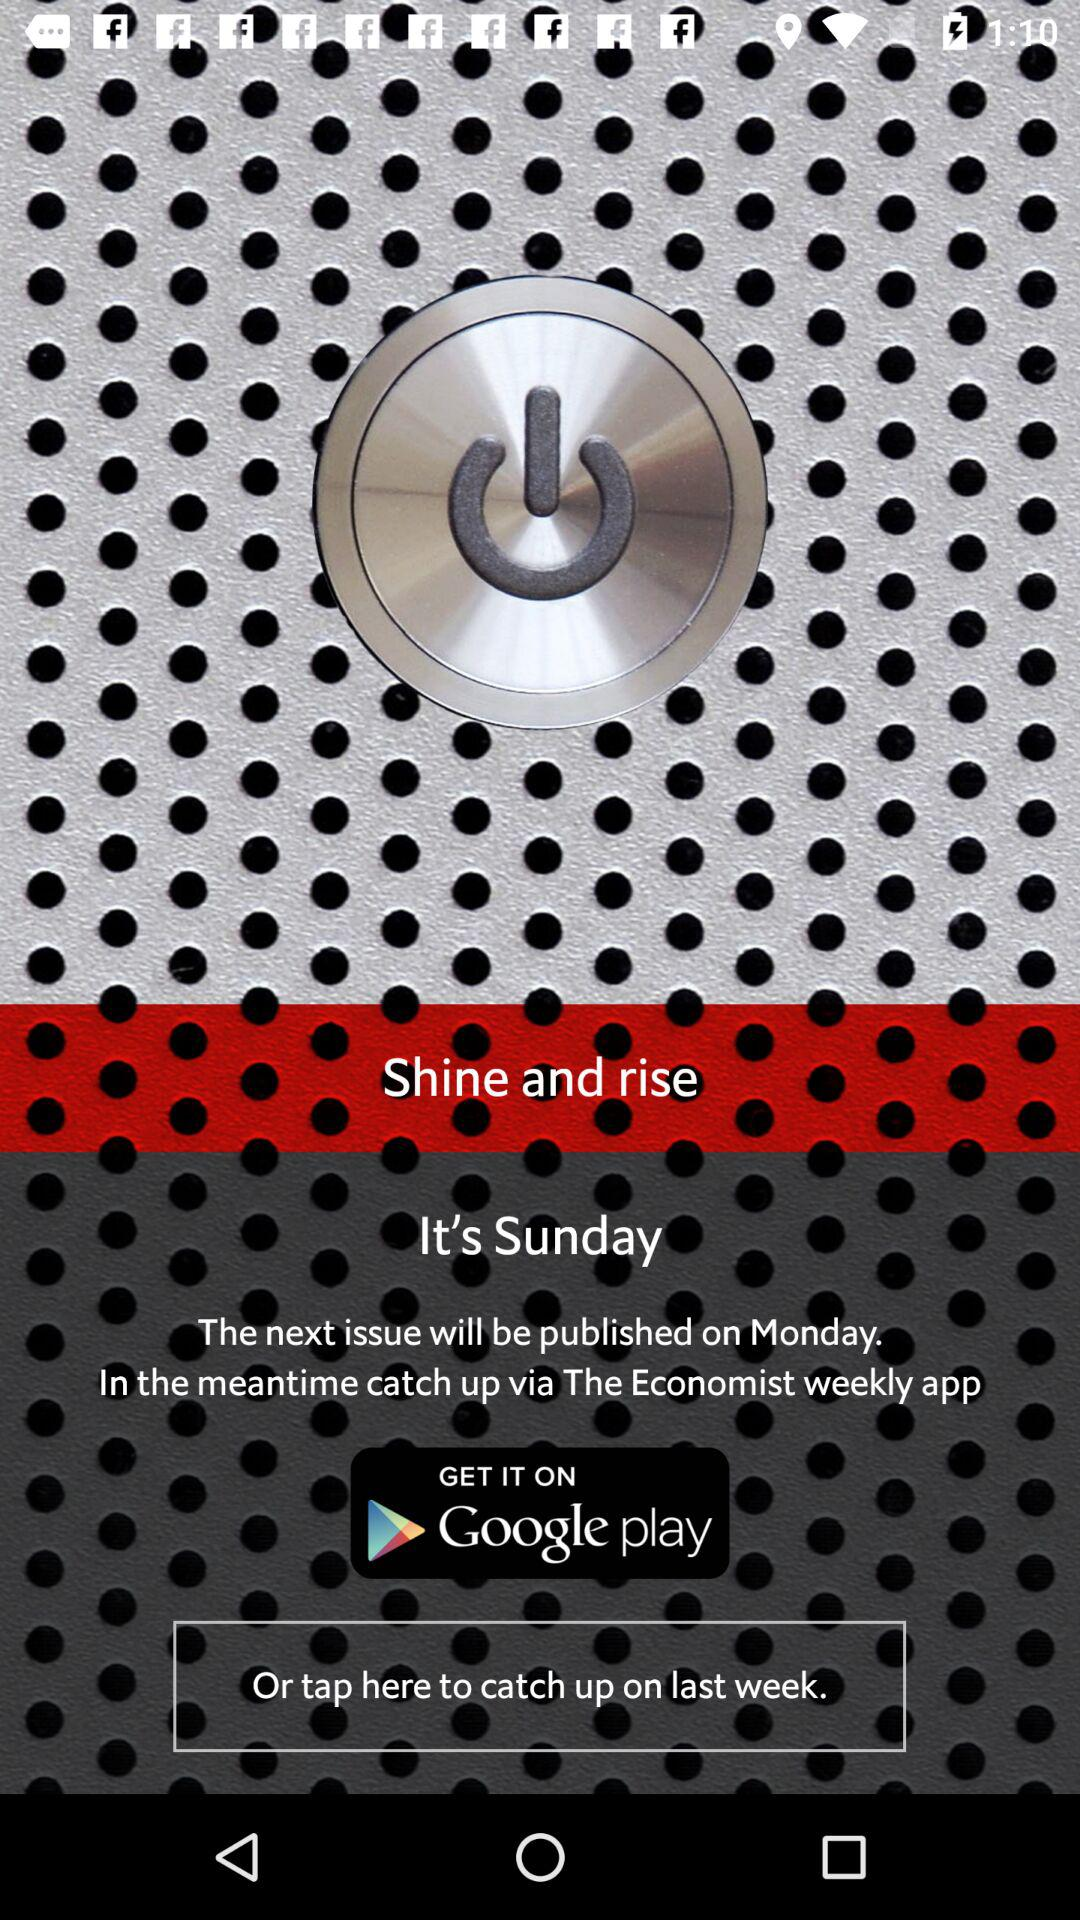On which day will the next issue be published? The next issue will be published on Monday. 